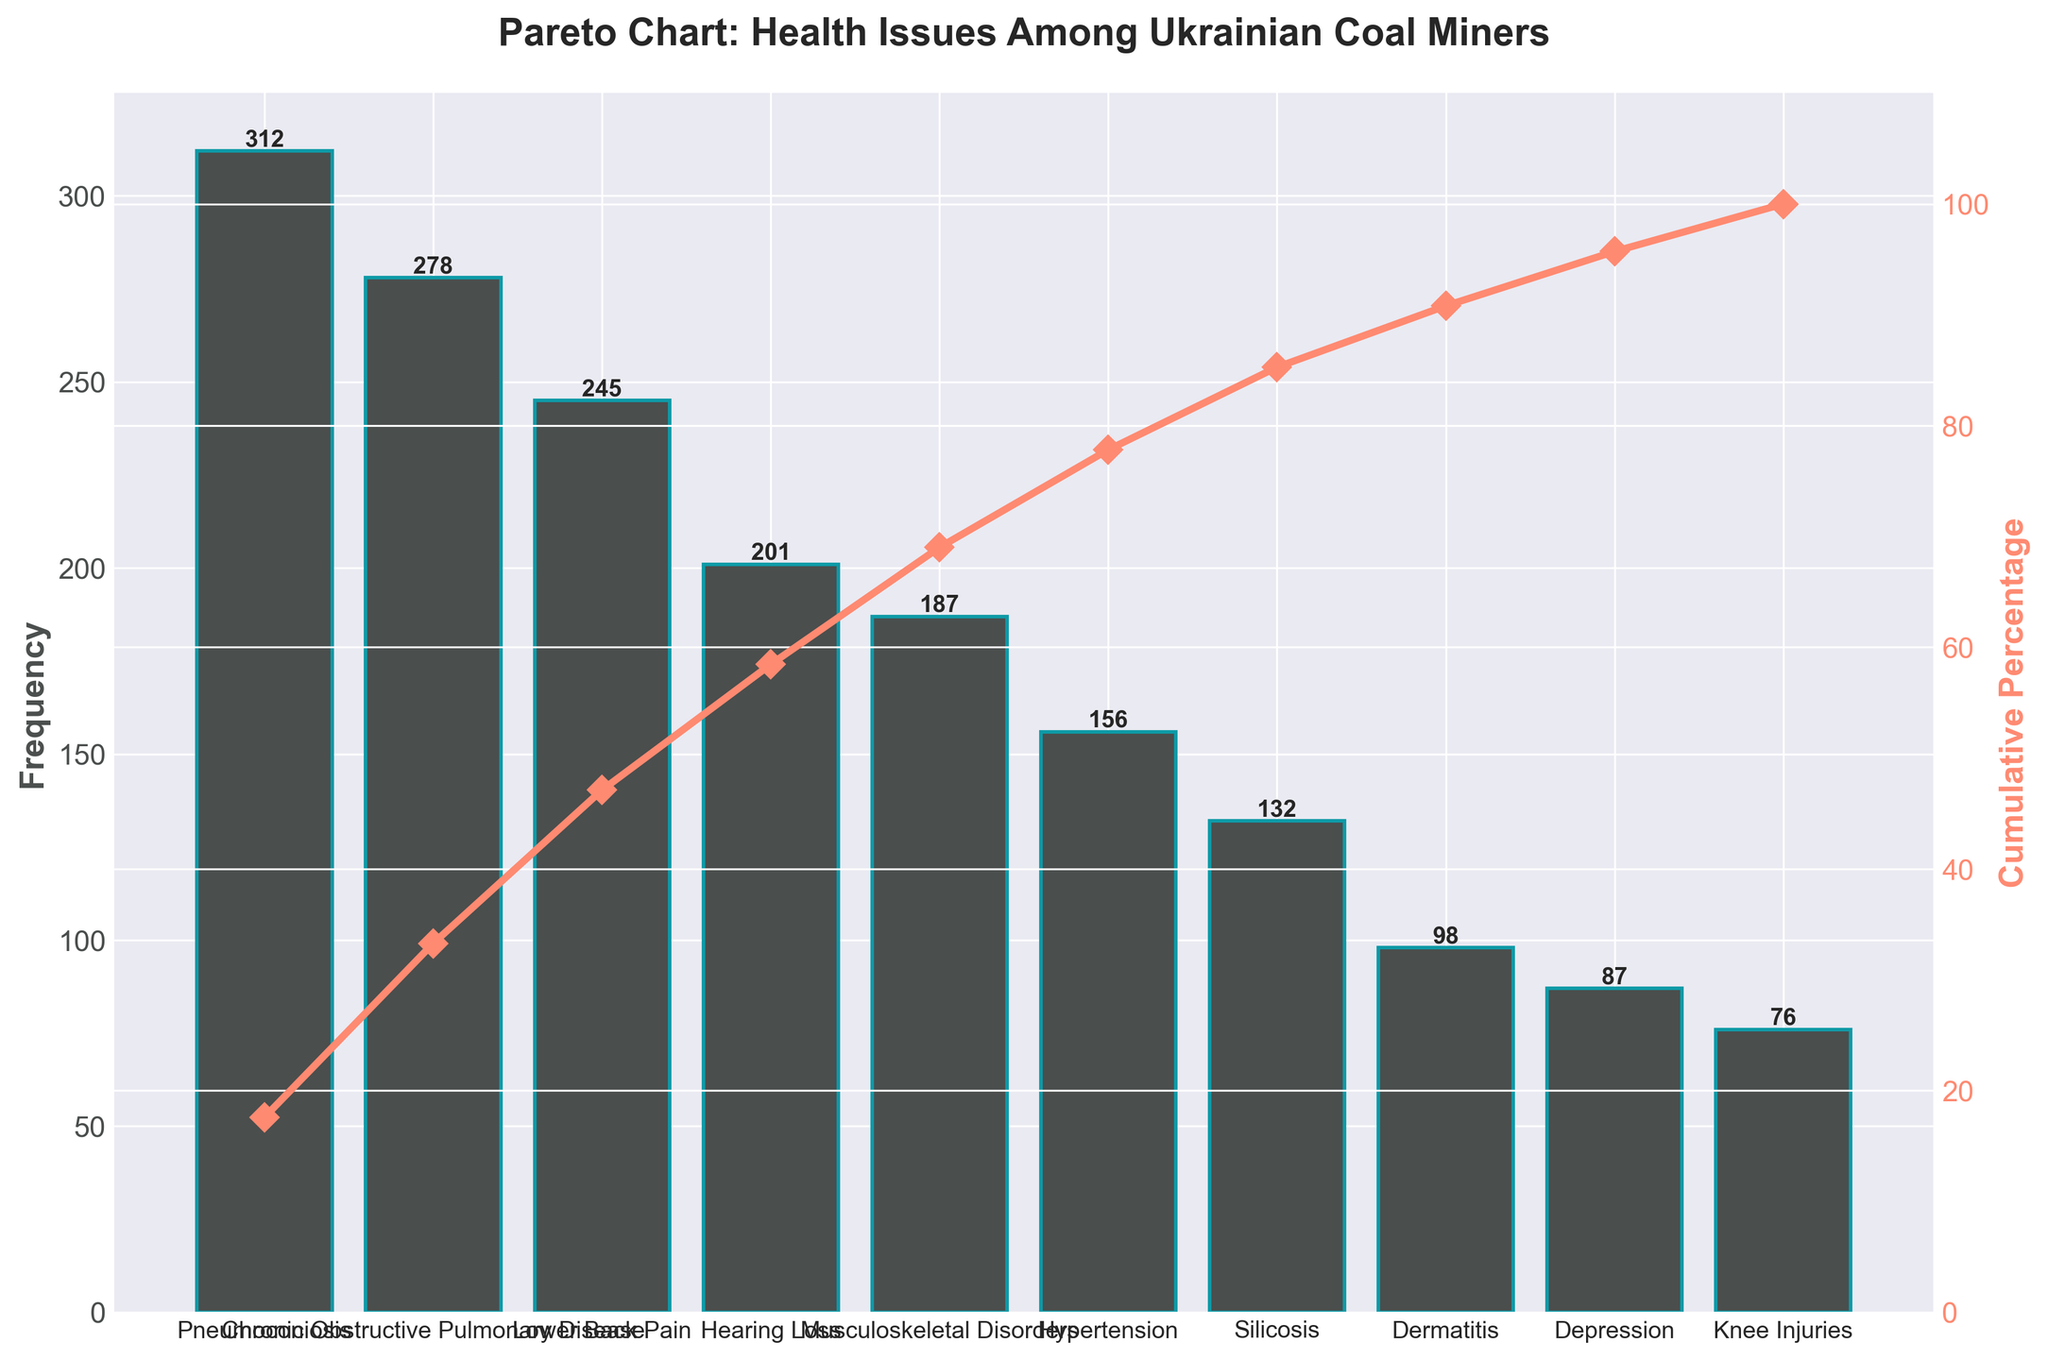What's the most common health issue among Ukrainian coal miners? The most common health issue is indicated by the tallest bar in the Pareto chart. In this case, it is Pneumoconiosis.
Answer: Pneumoconiosis How many health issues have a frequency greater than 200? Count the number of bars that have a height greater than 200 units on the y-axis (frequency). There are four such bars.
Answer: 4 What is the cumulative percentage for Hearing Loss? Locate the point on the cumulative percentage line that corresponds to Hearing Loss and read its value on the secondary y-axis. The value is close to 75%.
Answer: Approximately 75% Which health issue has the lowest frequency? The health issue with the shortest bar represents the lowest frequency. In this case, it is Knee Injuries.
Answer: Knee Injuries What's the difference in frequency between Chronic Obstructive Pulmonary Disease and Silicosis? Find the height of the bars for Chronic Obstructive Pulmonary Disease and Silicosis, which are 278 and 132 respectively. Subtract the smaller value from the larger one (278 - 132).
Answer: 146 What cumulative percentage covers the top three health issues? Find the cumulative percentage value at the third health issue (Lower Back Pain) on the x-axis. The cumulative percentage there is close to 60%.
Answer: Approximately 60% Which health issue contributes to reaching about 50% of the cumulative percentage? Follow the cumulative percentage line until you reach about 50%, then drop down to the corresponding health issue. This is approximately at Chronic Obstructive Pulmonary Disease.
Answer: Chronic Obstructive Pulmonary Disease How many health issues have a cumulative percentage less than 80%? Identify the health issues from the left until the cumulative percentage line reaches 80%. This includes Pneumoconiosis, Chronic Obstructive Pulmonary Disease, Lower Back Pain, Hearing Loss, and Musculoskeletal Disorders.
Answer: 5 What is the second most common health issue among Ukrainian coal miners? The second tallest bar in the Pareto chart indicates the second most common health issue, which is Chronic Obstructive Pulmonary Disease.
Answer: Chronic Obstructive Pulmonary Disease What percentage of the total issues does Hypertension and Silicosis together account for? Find the heights of the bars for Hypertension and Silicosis, which are 156 and 132 respectively. Sum these values (156 + 132 = 288). Divide by the total number of frequencies (sum of all bars) and multiply by 100 to find the percentage. Total frequencies sum to 1772. So, (288 / 1772) * 100 ≈ 16.3%.
Answer: Approximately 16.3% 